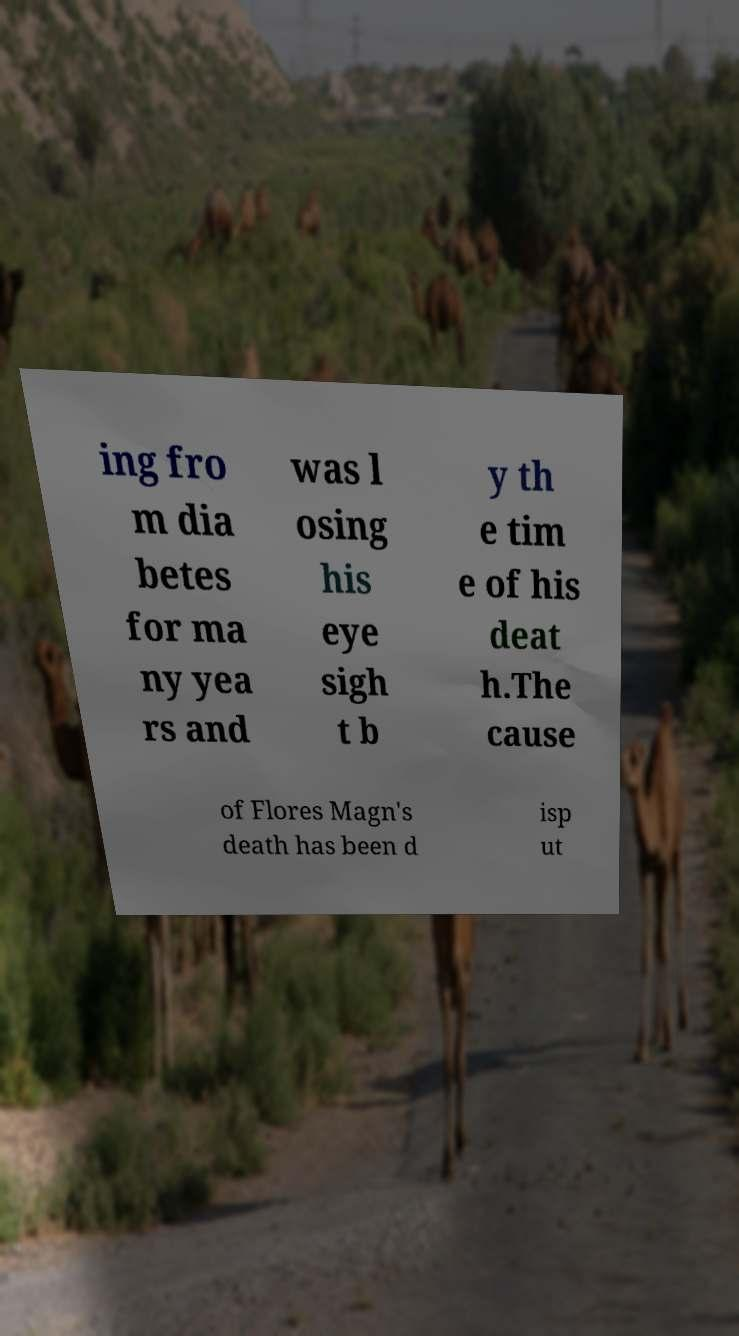Could you assist in decoding the text presented in this image and type it out clearly? ing fro m dia betes for ma ny yea rs and was l osing his eye sigh t b y th e tim e of his deat h.The cause of Flores Magn's death has been d isp ut 